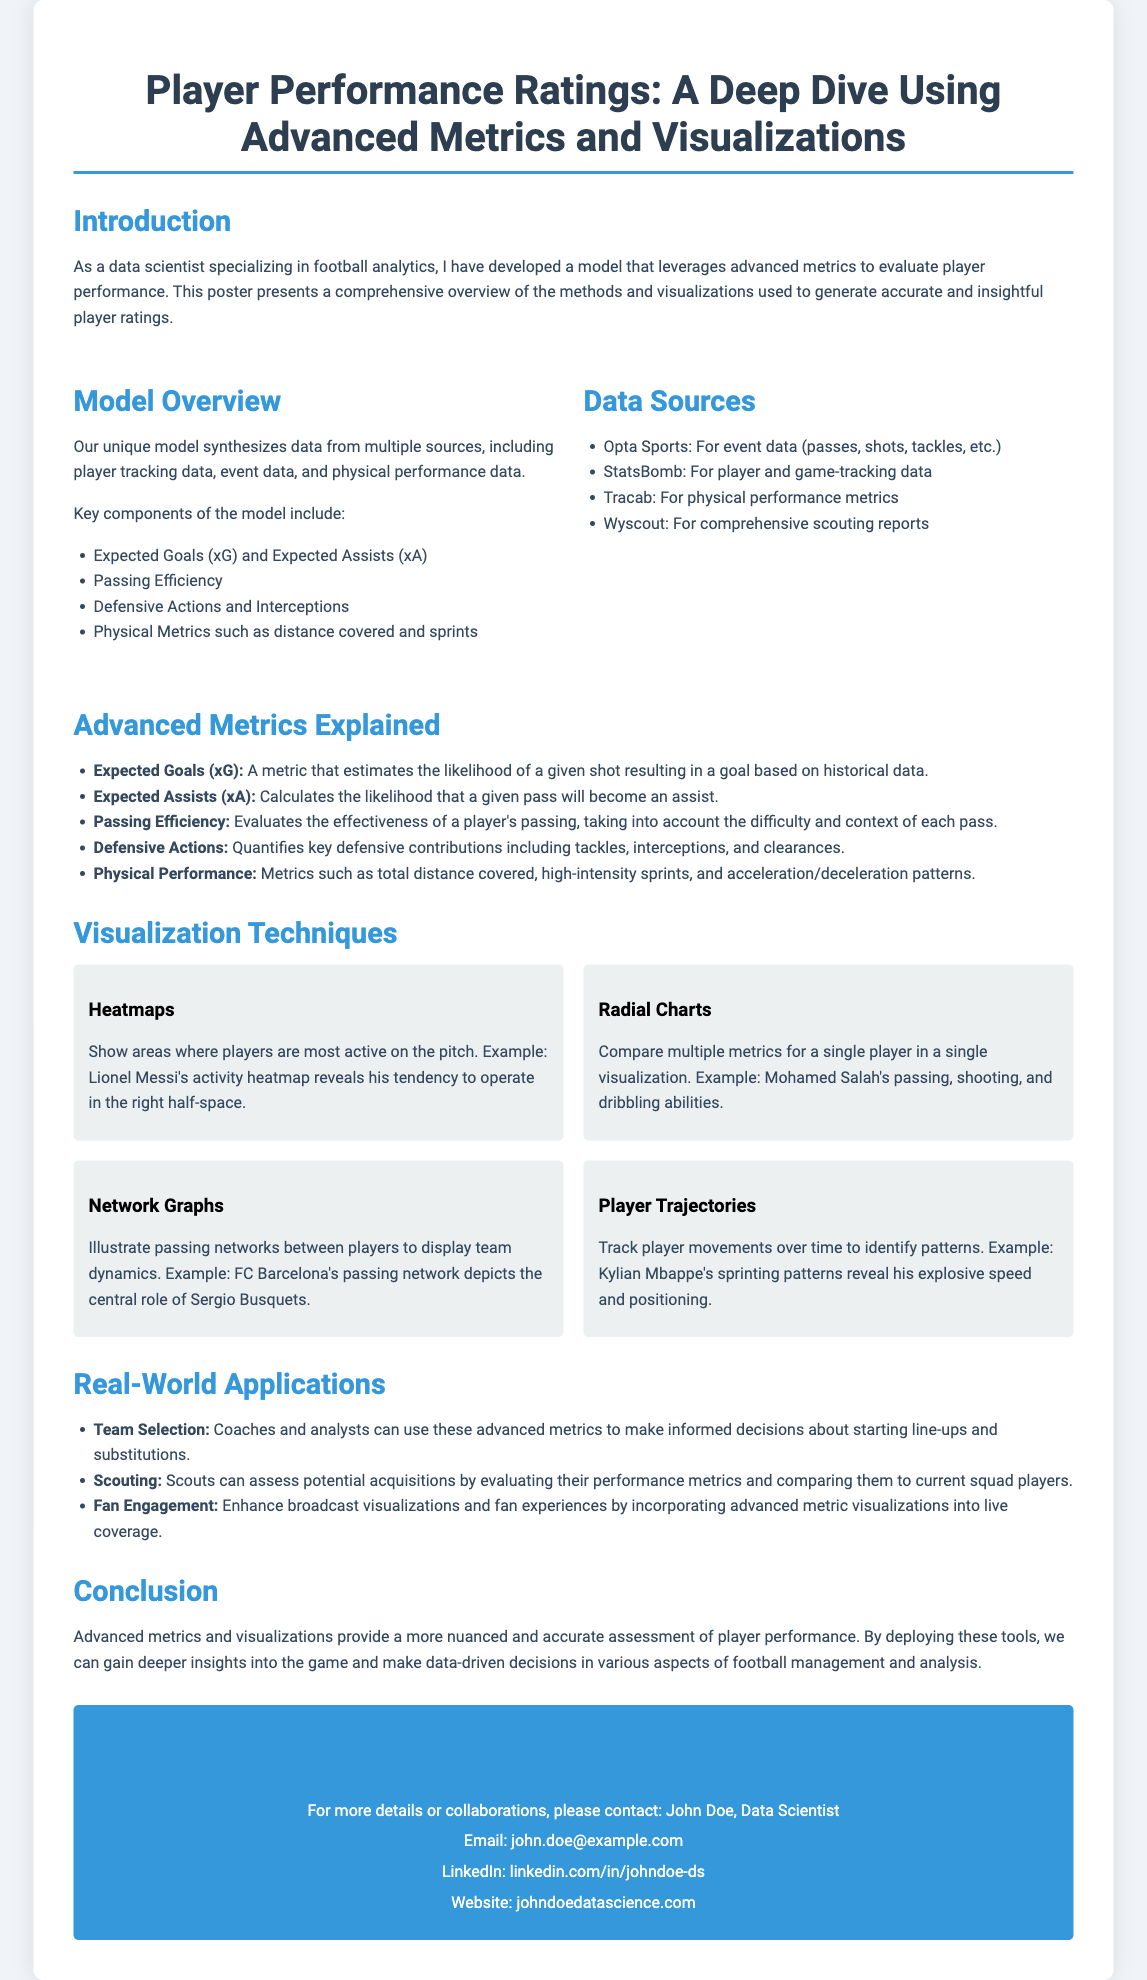what is the title of the poster? The title of the poster is presented as the main heading at the top of the document.
Answer: Player Performance Ratings: A Deep Dive Using Advanced Metrics and Visualizations who developed the model presented in the poster? The model was developed by the data scientist who specializes in football analytics, as mentioned in the introduction.
Answer: I what are the key components of the model? The document lists several components that are crucial to the model in the Model Overview section.
Answer: Expected Goals (xG) and Expected Assists (xA), Passing Efficiency, Defensive Actions and Interceptions, Physical Metrics which data source provides event data such as passes and shots? The document specifies which source provides event data in the Data Sources section.
Answer: Opta Sports what does xG stand for? xG is defined in the Advanced Metrics Explained section of the poster.
Answer: Expected Goals how can advanced metrics assist in team selection? The Real-World Applications section discusses how advanced metrics can be used for specific purposes within teams.
Answer: Informed decisions what visualization technique shows areas of player activity on the pitch? The Visualization Techniques section describes different methods used to visualize player performance.
Answer: Heatmaps who can be contacted for more details or collaborations? The Contact Information section provides the name of the person to contact for inquiries.
Answer: John Doe what is the email address provided in the contact information? The document specifies the email address under the Contact Information section.
Answer: john.doe@example.com 